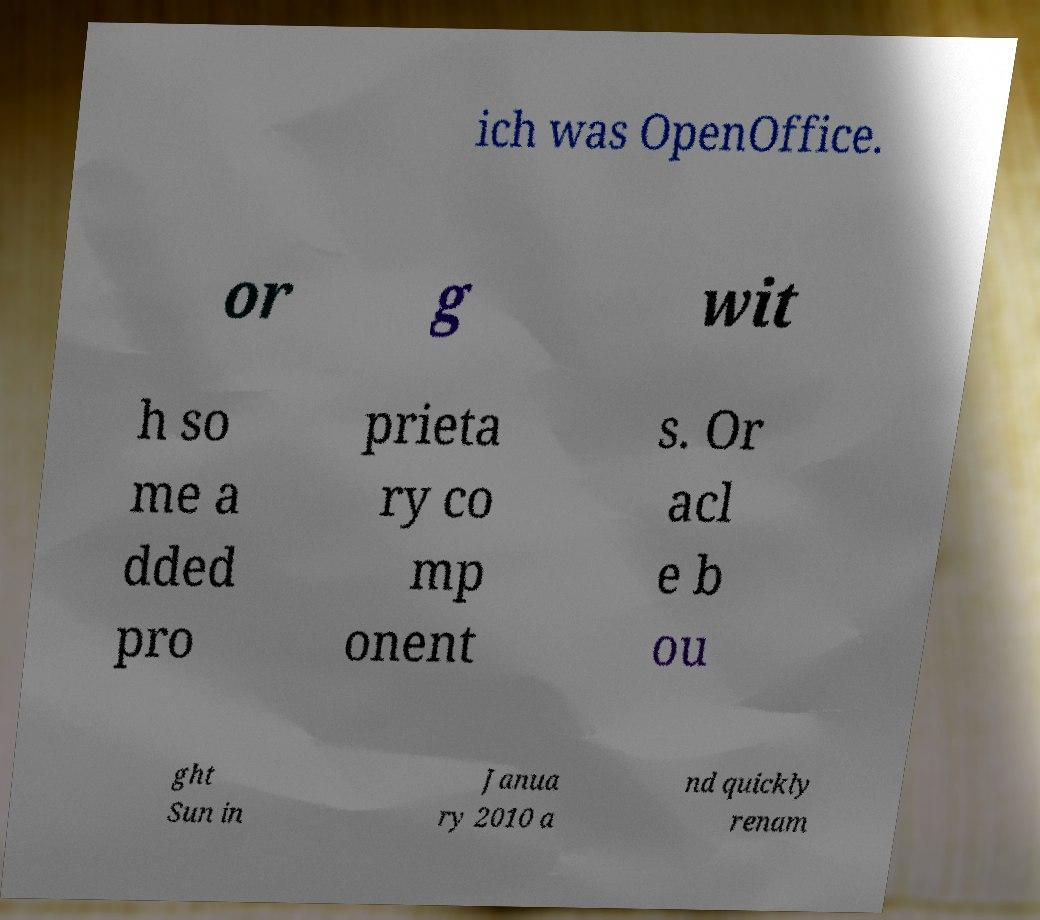Please read and relay the text visible in this image. What does it say? ich was OpenOffice. or g wit h so me a dded pro prieta ry co mp onent s. Or acl e b ou ght Sun in Janua ry 2010 a nd quickly renam 